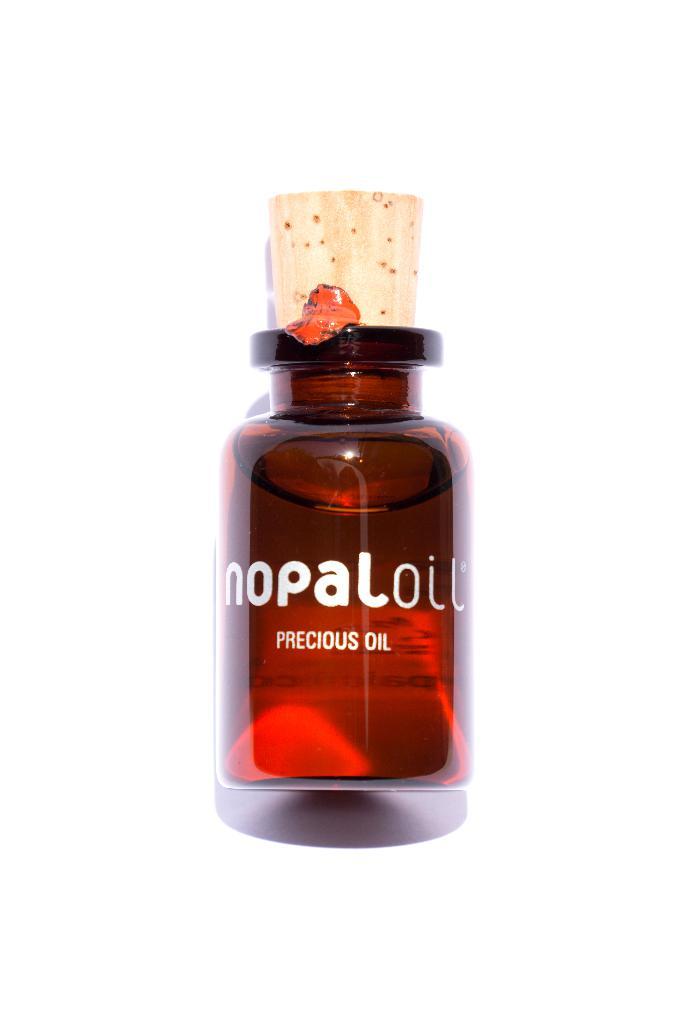Can yu tell me the name of this oil?
Your answer should be very brief. Nopaloil. What type of precious oil is this?
Offer a terse response. Nopal oil. 